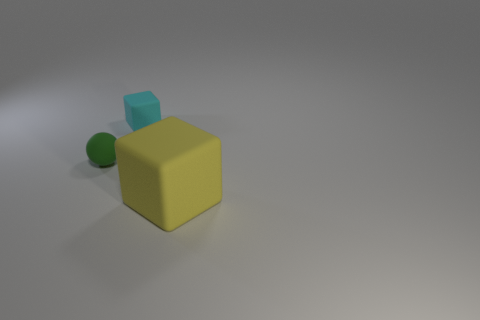How many spheres are either yellow rubber objects or small green things?
Keep it short and to the point. 1. Are there any small blue metal balls?
Give a very brief answer. No. What is the size of the cyan thing that is the same shape as the yellow object?
Your response must be concise. Small. The object that is on the right side of the object behind the small green thing is what shape?
Make the answer very short. Cube. How many yellow things are rubber balls or big cubes?
Ensure brevity in your answer.  1. What is the color of the big matte block?
Provide a succinct answer. Yellow. Do the yellow rubber cube and the green sphere have the same size?
Offer a very short reply. No. Are there any other things that have the same shape as the big thing?
Offer a terse response. Yes. Is the cyan cube made of the same material as the thing that is on the left side of the cyan matte thing?
Provide a short and direct response. Yes. There is a rubber block that is behind the green thing; is its color the same as the large object?
Provide a succinct answer. No. 